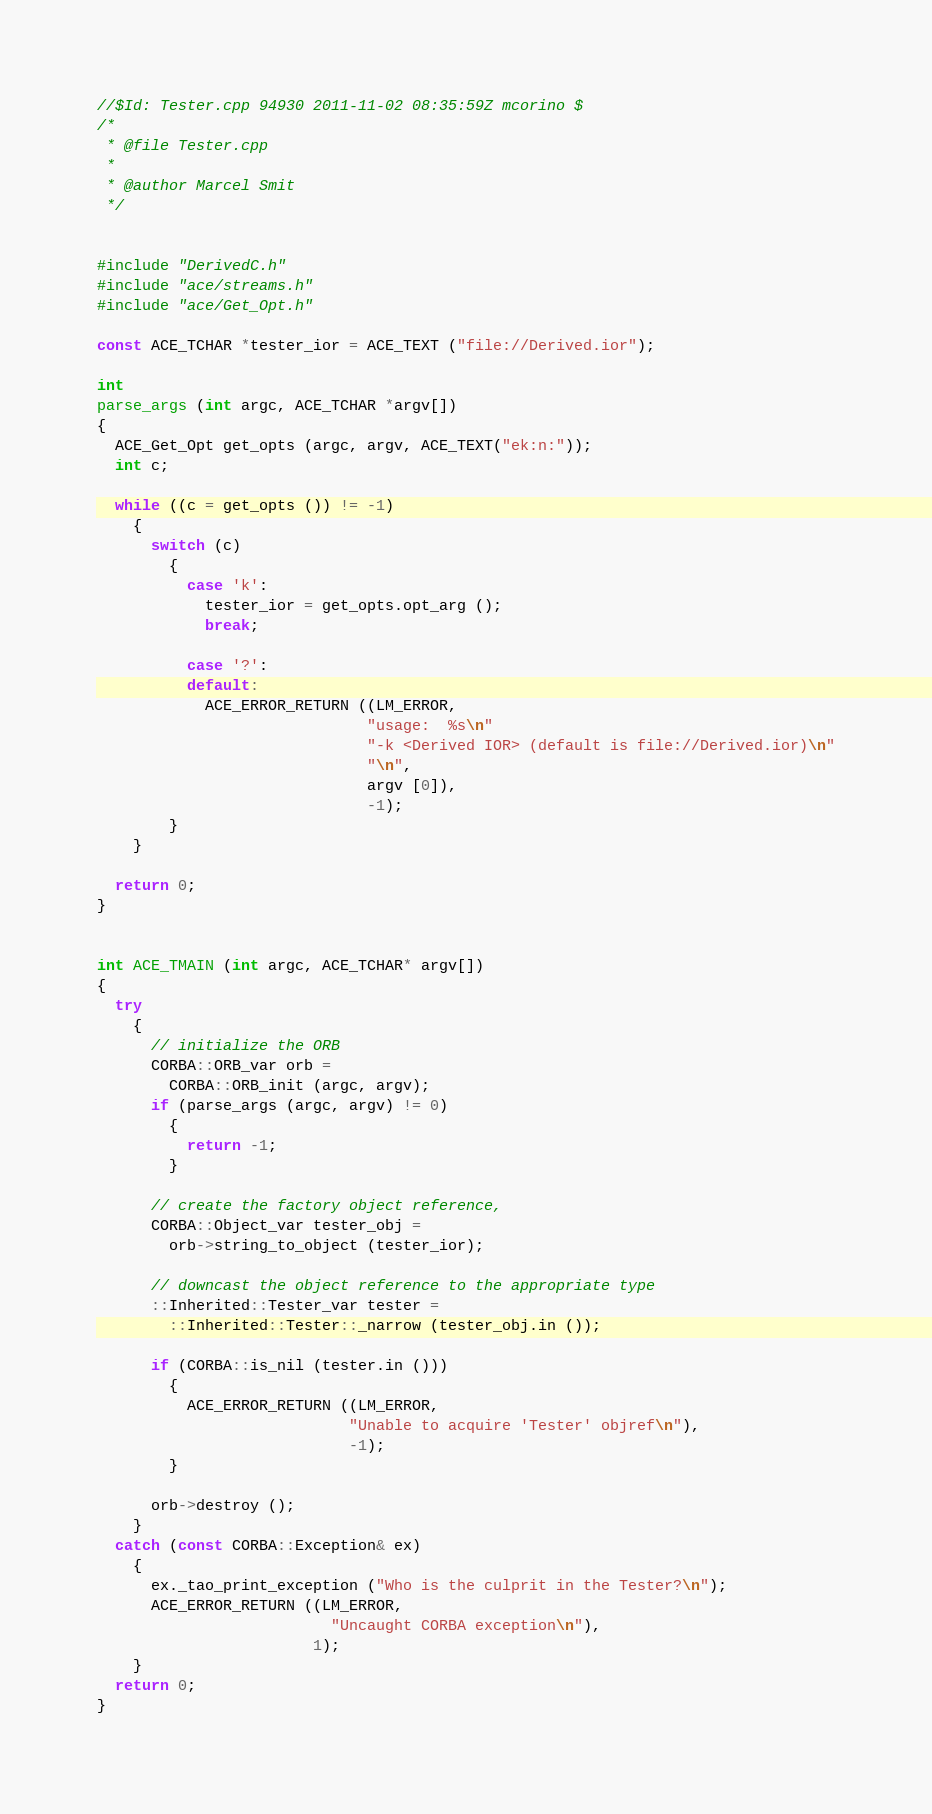Convert code to text. <code><loc_0><loc_0><loc_500><loc_500><_C++_>//$Id: Tester.cpp 94930 2011-11-02 08:35:59Z mcorino $
/*
 * @file Tester.cpp
 *
 * @author Marcel Smit
 */


#include "DerivedC.h"
#include "ace/streams.h"
#include "ace/Get_Opt.h"

const ACE_TCHAR *tester_ior = ACE_TEXT ("file://Derived.ior");

int
parse_args (int argc, ACE_TCHAR *argv[])
{
  ACE_Get_Opt get_opts (argc, argv, ACE_TEXT("ek:n:"));
  int c;

  while ((c = get_opts ()) != -1)
    {
      switch (c)
        {
          case 'k':
            tester_ior = get_opts.opt_arg ();
            break;

          case '?':
          default:
            ACE_ERROR_RETURN ((LM_ERROR,
                              "usage:  %s\n"
                              "-k <Derived IOR> (default is file://Derived.ior)\n"
                              "\n",
                              argv [0]),
                              -1);
        }
    }

  return 0;
}


int ACE_TMAIN (int argc, ACE_TCHAR* argv[])
{
  try
    {
      // initialize the ORB
      CORBA::ORB_var orb =
        CORBA::ORB_init (argc, argv);
      if (parse_args (argc, argv) != 0)
        {
          return -1;
        }

      // create the factory object reference,
      CORBA::Object_var tester_obj =
        orb->string_to_object (tester_ior);

      // downcast the object reference to the appropriate type
      ::Inherited::Tester_var tester =
        ::Inherited::Tester::_narrow (tester_obj.in ());

      if (CORBA::is_nil (tester.in ()))
        {
          ACE_ERROR_RETURN ((LM_ERROR,
                            "Unable to acquire 'Tester' objref\n"),
                            -1);
        }

      orb->destroy ();
    }
  catch (const CORBA::Exception& ex)
    {
      ex._tao_print_exception ("Who is the culprit in the Tester?\n");
      ACE_ERROR_RETURN ((LM_ERROR,
                          "Uncaught CORBA exception\n"),
                        1);
    }
  return 0;
}
</code> 